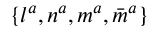Convert formula to latex. <formula><loc_0><loc_0><loc_500><loc_500>\{ l ^ { a } , n ^ { a } , m ^ { a } , { \bar { m } } ^ { a } \}</formula> 